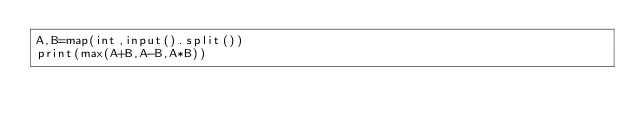<code> <loc_0><loc_0><loc_500><loc_500><_Python_>A,B=map(int,input().split())
print(max(A+B,A-B,A*B))</code> 